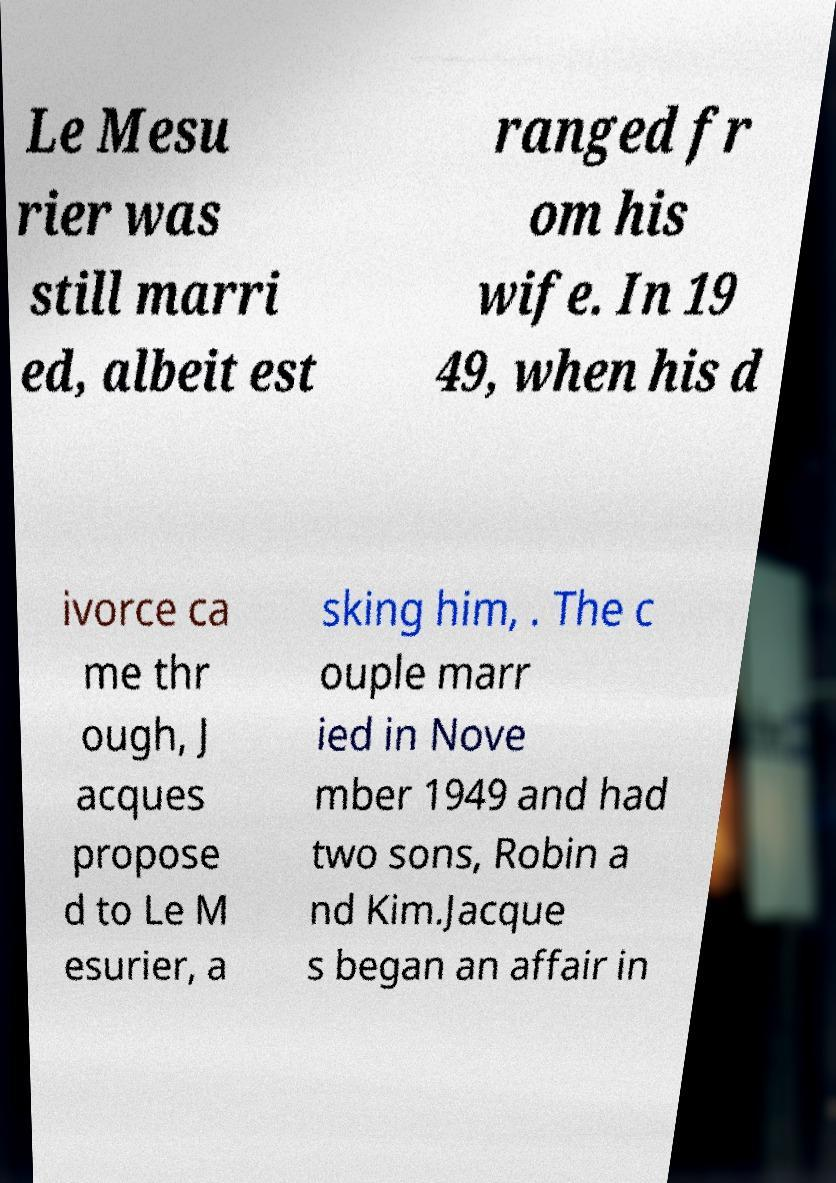Could you extract and type out the text from this image? Le Mesu rier was still marri ed, albeit est ranged fr om his wife. In 19 49, when his d ivorce ca me thr ough, J acques propose d to Le M esurier, a sking him, . The c ouple marr ied in Nove mber 1949 and had two sons, Robin a nd Kim.Jacque s began an affair in 